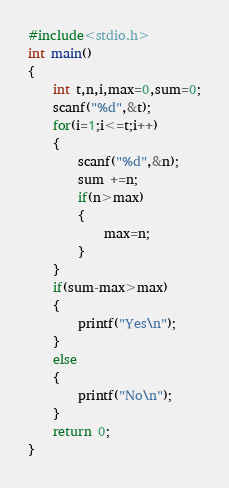Convert code to text. <code><loc_0><loc_0><loc_500><loc_500><_C_>#include<stdio.h>
int main()
{
    int t,n,i,max=0,sum=0;
    scanf("%d",&t);
    for(i=1;i<=t;i++)
    {
        scanf("%d",&n);
        sum +=n;
        if(n>max)
        {
            max=n;
        }
    }
    if(sum-max>max)
    {
        printf("Yes\n");
    }
    else
    {
        printf("No\n");
    }
    return 0;
}
</code> 